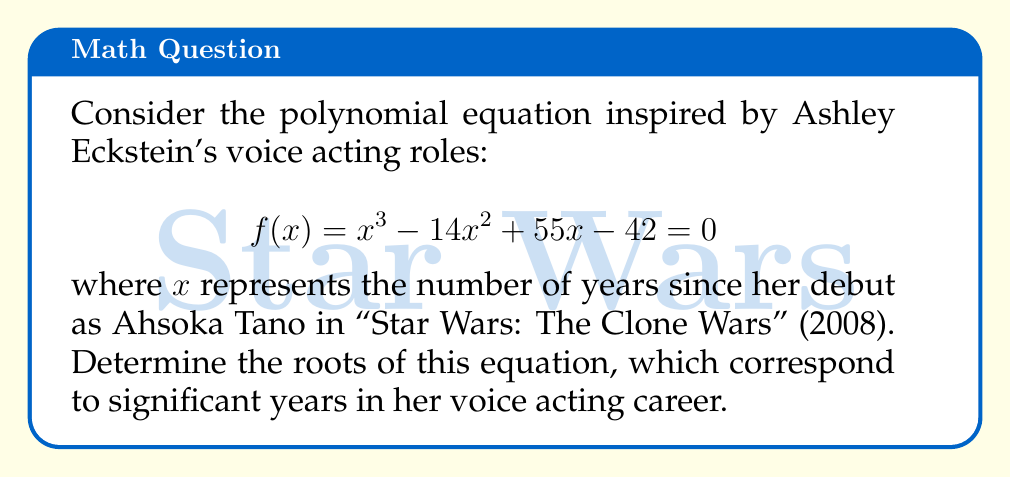Provide a solution to this math problem. Let's solve this step-by-step:

1) First, we can try to factor out any common factors. In this case, there are none.

2) Next, we can check if there are any rational roots using the rational root theorem. The possible rational roots are the factors of the constant term 42: ±1, ±2, ±3, ±6, ±7, ±14, ±21, ±42.

3) Testing these values, we find that x = 2 is a root. So (x - 2) is a factor of the polynomial.

4) Dividing f(x) by (x - 2) using polynomial long division:

   $x^3 - 14x^2 + 55x - 42 = (x - 2)(x^2 - 12x + 21)$

5) Now we need to solve $x^2 - 12x + 21 = 0$

6) This is a quadratic equation. We can solve it using the quadratic formula:
   
   $x = \frac{-b \pm \sqrt{b^2 - 4ac}}{2a}$

   where a = 1, b = -12, and c = 21

7) Substituting these values:

   $x = \frac{12 \pm \sqrt{144 - 84}}{2} = \frac{12 \pm \sqrt{60}}{2} = \frac{12 \pm 2\sqrt{15}}{2}$

8) Simplifying:

   $x = 6 \pm \sqrt{15}$

Therefore, the roots are:
x = 2, x = 6 + √15, and x = 6 - √15

These correspond to years 2010, approximately 2014, and approximately 2002 (interpreting negative results as years before 2008).
Answer: x = 2, x = 6 + √15, x = 6 - √15 